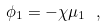<formula> <loc_0><loc_0><loc_500><loc_500>\phi _ { 1 } = - \chi \mu _ { 1 } \ ,</formula> 